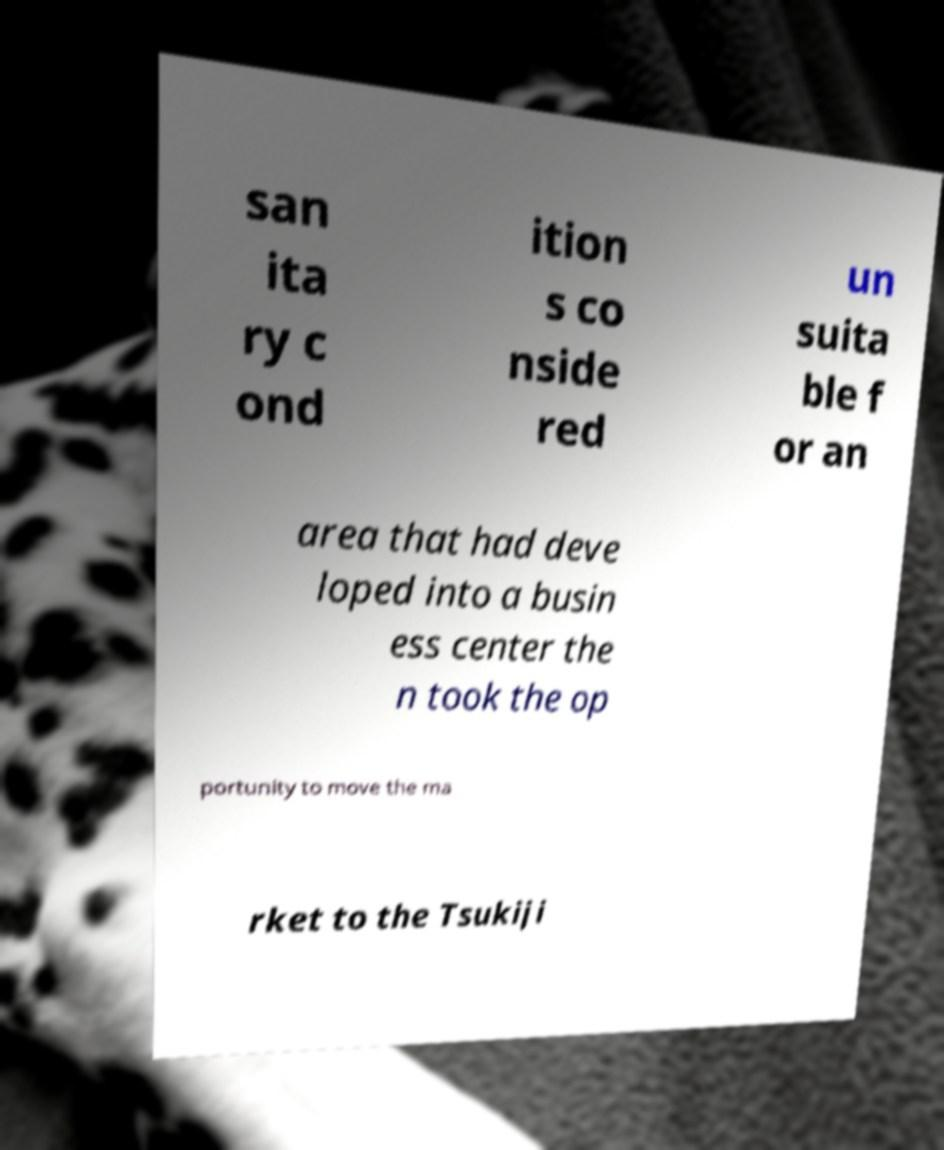For documentation purposes, I need the text within this image transcribed. Could you provide that? san ita ry c ond ition s co nside red un suita ble f or an area that had deve loped into a busin ess center the n took the op portunity to move the ma rket to the Tsukiji 